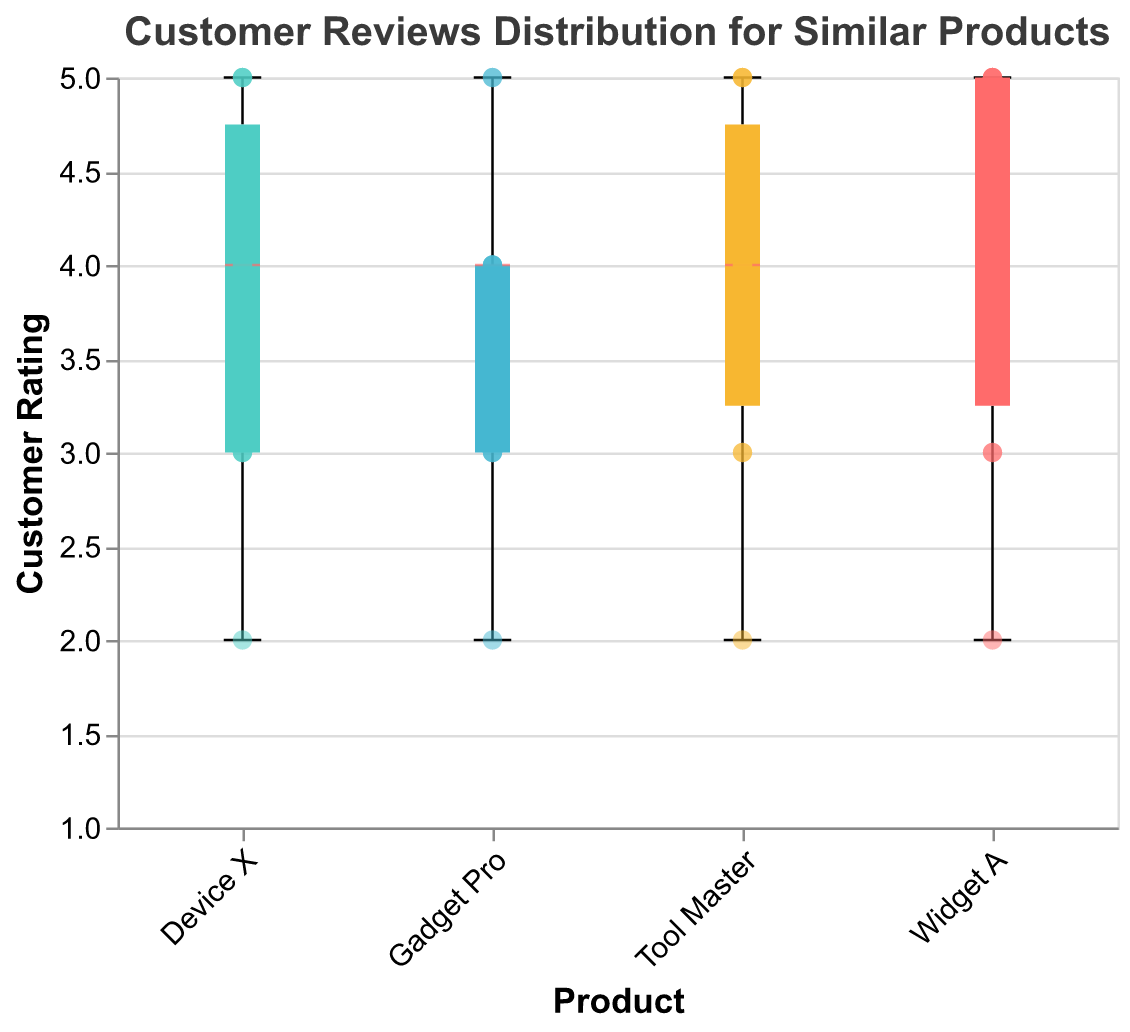How many different products are shown in the figure? By observing the x-axis, which lists the products, we see "Widget A," "Gadget Pro," "Tool Master," and "Device X."
Answer: 4 Which product has the widest spread in customer ratings? The spread in ratings is represented by the length of the boxplot. "Widget A" has ratings ranging from 2 to 5, which is the widest spread among the products depicted.
Answer: Widget A What is the median rating for "Gadget Pro"? The median rating is indicated by the line inside the boxplot. For "Gadget Pro," the median line is at 4.
Answer: 4 Which product has the highest average customer rating? To determine the highest average rating, we look at the general position of the central line within each boxplot. "Widget A" and "Tool Master" both have most of their ratings at or above 4, but "Widget A" appears to have more ratings at 5, indicating a higher average.
Answer: Widget A Compare the minimum rating of "Tool Master" with that of "Device X." Which is lower? The minimum rating is indicated by the bottom whisker of the boxplot. "Tool Master" has a minimum rating of 2, while "Device X" also has a minimum rating of 2. They are equal.
Answer: equal For "Widget A," how many distinct ratings are there according to the scatter points? By observing the scatter points, we notice ratings of 2, 3, 4, and 5 given to "Widget A." This counts as four distinct ratings.
Answer: 4 Is there any product with no ratings of 2 or 3? By observing the scatter points and the boxplots, we can see that all products have ratings of at least 2 or 3.
Answer: no Which product has the most consistent ratings? The consistency in ratings is represented by the shortest interquartile range (the height of the boxplot). "Tool Master" appears to have the shortest range, indicating more consistent ratings.
Answer: Tool Master Compare the maximum rating of "Gadget Pro" and "Device X." Which one is higher? The maximum rating is indicated by the top whisker of the boxplot. Both "Gadget Pro" and "Device X" have a maximum rating of 5.
Answer: equal What is the average rating for "Device X"? The average requires calculating the mean of the individual ratings. "Device X" has the ratings: 5, 4, 3, 5, 3, 4, 5, 3, 4, 2. Summing these gives 38. Dividing by 10 (the total number of ratings) results in an average of 3.8.
Answer: 3.8 